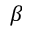Convert formula to latex. <formula><loc_0><loc_0><loc_500><loc_500>\beta</formula> 